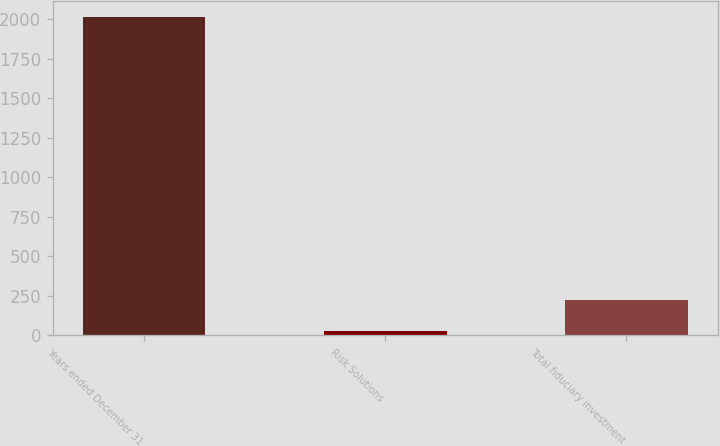<chart> <loc_0><loc_0><loc_500><loc_500><bar_chart><fcel>Years ended December 31<fcel>Risk Solutions<fcel>Total fiduciary investment<nl><fcel>2013<fcel>28<fcel>226.5<nl></chart> 